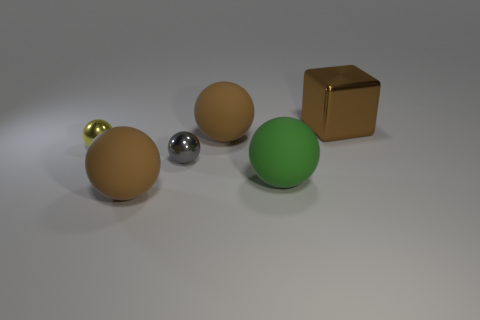What is the size of the yellow shiny object that is the same shape as the tiny gray object?
Provide a short and direct response. Small. How many other things are there of the same material as the yellow object?
Ensure brevity in your answer.  2. Is the big cube made of the same material as the big sphere that is behind the gray thing?
Offer a very short reply. No. Are there fewer yellow metal objects to the right of the gray metal object than yellow shiny things that are in front of the yellow metallic object?
Offer a very short reply. No. There is a tiny metal thing that is to the left of the small gray metallic ball; what color is it?
Provide a short and direct response. Yellow. What number of other things are there of the same color as the big metallic object?
Your answer should be very brief. 2. Is the size of the rubber object that is behind the green ball the same as the large metal thing?
Offer a very short reply. Yes. There is a yellow thing; what number of yellow metal balls are on the left side of it?
Provide a succinct answer. 0. Are there any green spheres of the same size as the gray ball?
Ensure brevity in your answer.  No. What is the color of the matte object to the left of the large ball that is behind the tiny yellow object?
Your response must be concise. Brown. 